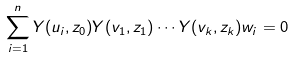Convert formula to latex. <formula><loc_0><loc_0><loc_500><loc_500>\sum _ { i = 1 } ^ { n } Y ( u _ { i } , z _ { 0 } ) Y ( v _ { 1 } , z _ { 1 } ) \cdots Y ( v _ { k } , z _ { k } ) w _ { i } = 0</formula> 